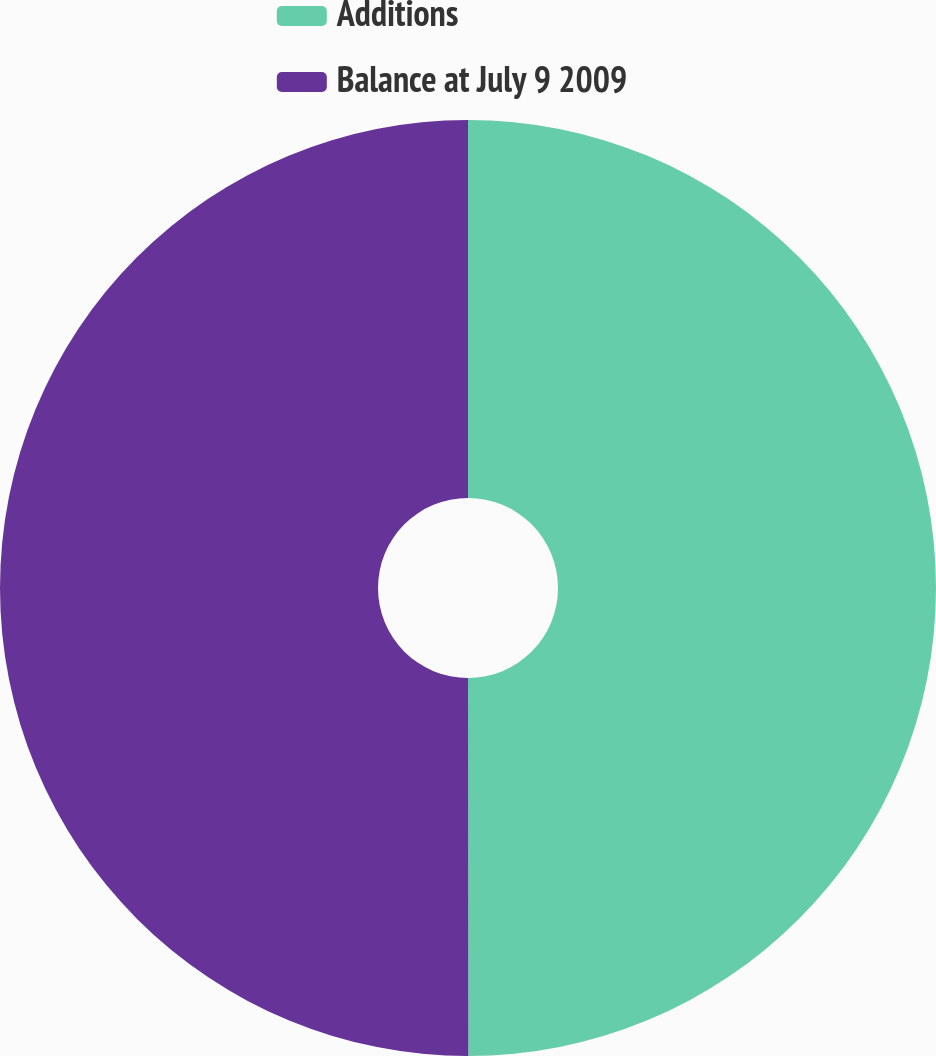Convert chart to OTSL. <chart><loc_0><loc_0><loc_500><loc_500><pie_chart><fcel>Additions<fcel>Balance at July 9 2009<nl><fcel>49.99%<fcel>50.01%<nl></chart> 